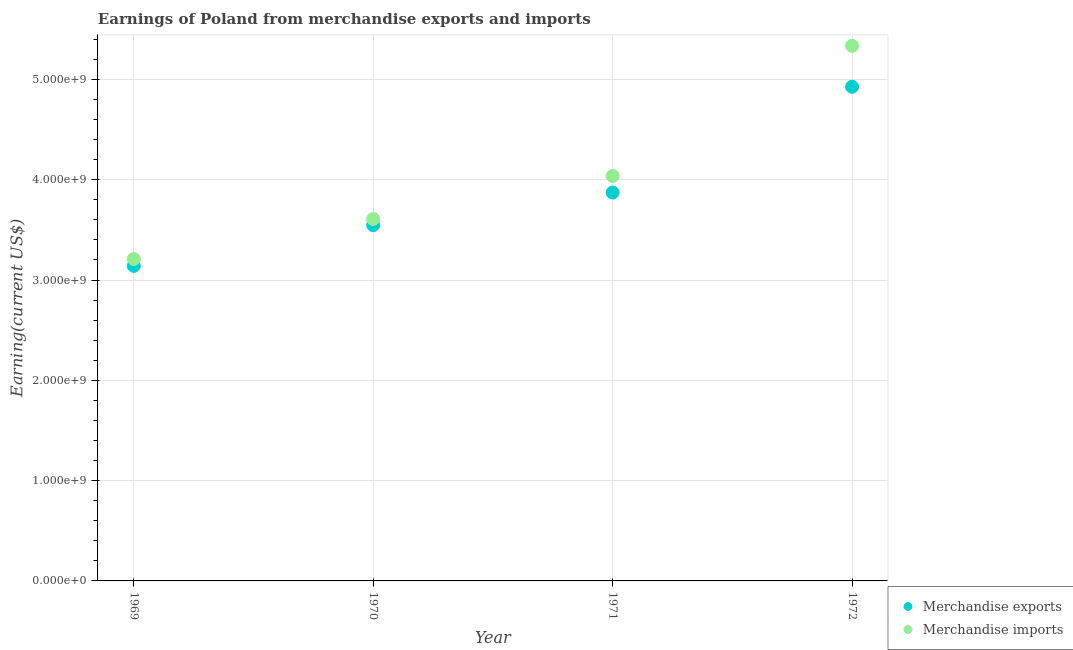What is the earnings from merchandise imports in 1972?
Your answer should be very brief. 5.34e+09. Across all years, what is the maximum earnings from merchandise imports?
Keep it short and to the point. 5.34e+09. Across all years, what is the minimum earnings from merchandise imports?
Offer a terse response. 3.21e+09. In which year was the earnings from merchandise imports minimum?
Provide a short and direct response. 1969. What is the total earnings from merchandise exports in the graph?
Make the answer very short. 1.55e+1. What is the difference between the earnings from merchandise imports in 1970 and that in 1972?
Offer a terse response. -1.73e+09. What is the difference between the earnings from merchandise imports in 1972 and the earnings from merchandise exports in 1971?
Offer a terse response. 1.46e+09. What is the average earnings from merchandise exports per year?
Provide a short and direct response. 3.87e+09. In the year 1972, what is the difference between the earnings from merchandise exports and earnings from merchandise imports?
Ensure brevity in your answer.  -4.08e+08. What is the ratio of the earnings from merchandise imports in 1969 to that in 1972?
Offer a very short reply. 0.6. Is the earnings from merchandise exports in 1970 less than that in 1972?
Provide a short and direct response. Yes. What is the difference between the highest and the second highest earnings from merchandise exports?
Offer a terse response. 1.06e+09. What is the difference between the highest and the lowest earnings from merchandise exports?
Give a very brief answer. 1.79e+09. In how many years, is the earnings from merchandise exports greater than the average earnings from merchandise exports taken over all years?
Ensure brevity in your answer.  2. Is the earnings from merchandise imports strictly greater than the earnings from merchandise exports over the years?
Offer a very short reply. Yes. How many years are there in the graph?
Your answer should be compact. 4. What is the difference between two consecutive major ticks on the Y-axis?
Your answer should be very brief. 1.00e+09. Are the values on the major ticks of Y-axis written in scientific E-notation?
Your answer should be very brief. Yes. Does the graph contain any zero values?
Ensure brevity in your answer.  No. What is the title of the graph?
Your response must be concise. Earnings of Poland from merchandise exports and imports. Does "External balance on goods" appear as one of the legend labels in the graph?
Your answer should be very brief. No. What is the label or title of the X-axis?
Your response must be concise. Year. What is the label or title of the Y-axis?
Offer a very short reply. Earning(current US$). What is the Earning(current US$) of Merchandise exports in 1969?
Make the answer very short. 3.14e+09. What is the Earning(current US$) of Merchandise imports in 1969?
Keep it short and to the point. 3.21e+09. What is the Earning(current US$) of Merchandise exports in 1970?
Ensure brevity in your answer.  3.55e+09. What is the Earning(current US$) of Merchandise imports in 1970?
Offer a terse response. 3.61e+09. What is the Earning(current US$) in Merchandise exports in 1971?
Your response must be concise. 3.87e+09. What is the Earning(current US$) in Merchandise imports in 1971?
Make the answer very short. 4.04e+09. What is the Earning(current US$) of Merchandise exports in 1972?
Give a very brief answer. 4.93e+09. What is the Earning(current US$) of Merchandise imports in 1972?
Offer a terse response. 5.34e+09. Across all years, what is the maximum Earning(current US$) of Merchandise exports?
Provide a short and direct response. 4.93e+09. Across all years, what is the maximum Earning(current US$) of Merchandise imports?
Give a very brief answer. 5.34e+09. Across all years, what is the minimum Earning(current US$) of Merchandise exports?
Offer a terse response. 3.14e+09. Across all years, what is the minimum Earning(current US$) of Merchandise imports?
Ensure brevity in your answer.  3.21e+09. What is the total Earning(current US$) of Merchandise exports in the graph?
Give a very brief answer. 1.55e+1. What is the total Earning(current US$) in Merchandise imports in the graph?
Give a very brief answer. 1.62e+1. What is the difference between the Earning(current US$) of Merchandise exports in 1969 and that in 1970?
Provide a succinct answer. -4.06e+08. What is the difference between the Earning(current US$) of Merchandise imports in 1969 and that in 1970?
Offer a very short reply. -3.98e+08. What is the difference between the Earning(current US$) of Merchandise exports in 1969 and that in 1971?
Your answer should be very brief. -7.31e+08. What is the difference between the Earning(current US$) in Merchandise imports in 1969 and that in 1971?
Ensure brevity in your answer.  -8.28e+08. What is the difference between the Earning(current US$) in Merchandise exports in 1969 and that in 1972?
Provide a succinct answer. -1.79e+09. What is the difference between the Earning(current US$) of Merchandise imports in 1969 and that in 1972?
Provide a succinct answer. -2.12e+09. What is the difference between the Earning(current US$) of Merchandise exports in 1970 and that in 1971?
Provide a short and direct response. -3.25e+08. What is the difference between the Earning(current US$) in Merchandise imports in 1970 and that in 1971?
Offer a terse response. -4.30e+08. What is the difference between the Earning(current US$) of Merchandise exports in 1970 and that in 1972?
Provide a short and direct response. -1.38e+09. What is the difference between the Earning(current US$) of Merchandise imports in 1970 and that in 1972?
Your answer should be compact. -1.73e+09. What is the difference between the Earning(current US$) in Merchandise exports in 1971 and that in 1972?
Your answer should be very brief. -1.06e+09. What is the difference between the Earning(current US$) of Merchandise imports in 1971 and that in 1972?
Make the answer very short. -1.30e+09. What is the difference between the Earning(current US$) of Merchandise exports in 1969 and the Earning(current US$) of Merchandise imports in 1970?
Your answer should be very brief. -4.66e+08. What is the difference between the Earning(current US$) of Merchandise exports in 1969 and the Earning(current US$) of Merchandise imports in 1971?
Keep it short and to the point. -8.96e+08. What is the difference between the Earning(current US$) of Merchandise exports in 1969 and the Earning(current US$) of Merchandise imports in 1972?
Offer a terse response. -2.19e+09. What is the difference between the Earning(current US$) in Merchandise exports in 1970 and the Earning(current US$) in Merchandise imports in 1971?
Your response must be concise. -4.90e+08. What is the difference between the Earning(current US$) in Merchandise exports in 1970 and the Earning(current US$) in Merchandise imports in 1972?
Give a very brief answer. -1.79e+09. What is the difference between the Earning(current US$) of Merchandise exports in 1971 and the Earning(current US$) of Merchandise imports in 1972?
Your answer should be compact. -1.46e+09. What is the average Earning(current US$) in Merchandise exports per year?
Make the answer very short. 3.87e+09. What is the average Earning(current US$) of Merchandise imports per year?
Provide a short and direct response. 4.05e+09. In the year 1969, what is the difference between the Earning(current US$) in Merchandise exports and Earning(current US$) in Merchandise imports?
Offer a very short reply. -6.85e+07. In the year 1970, what is the difference between the Earning(current US$) of Merchandise exports and Earning(current US$) of Merchandise imports?
Ensure brevity in your answer.  -6.04e+07. In the year 1971, what is the difference between the Earning(current US$) of Merchandise exports and Earning(current US$) of Merchandise imports?
Your response must be concise. -1.66e+08. In the year 1972, what is the difference between the Earning(current US$) in Merchandise exports and Earning(current US$) in Merchandise imports?
Offer a terse response. -4.08e+08. What is the ratio of the Earning(current US$) of Merchandise exports in 1969 to that in 1970?
Offer a terse response. 0.89. What is the ratio of the Earning(current US$) of Merchandise imports in 1969 to that in 1970?
Make the answer very short. 0.89. What is the ratio of the Earning(current US$) of Merchandise exports in 1969 to that in 1971?
Your answer should be very brief. 0.81. What is the ratio of the Earning(current US$) of Merchandise imports in 1969 to that in 1971?
Your response must be concise. 0.79. What is the ratio of the Earning(current US$) of Merchandise exports in 1969 to that in 1972?
Keep it short and to the point. 0.64. What is the ratio of the Earning(current US$) of Merchandise imports in 1969 to that in 1972?
Give a very brief answer. 0.6. What is the ratio of the Earning(current US$) of Merchandise exports in 1970 to that in 1971?
Ensure brevity in your answer.  0.92. What is the ratio of the Earning(current US$) in Merchandise imports in 1970 to that in 1971?
Your response must be concise. 0.89. What is the ratio of the Earning(current US$) in Merchandise exports in 1970 to that in 1972?
Ensure brevity in your answer.  0.72. What is the ratio of the Earning(current US$) in Merchandise imports in 1970 to that in 1972?
Offer a very short reply. 0.68. What is the ratio of the Earning(current US$) of Merchandise exports in 1971 to that in 1972?
Keep it short and to the point. 0.79. What is the ratio of the Earning(current US$) of Merchandise imports in 1971 to that in 1972?
Your answer should be very brief. 0.76. What is the difference between the highest and the second highest Earning(current US$) of Merchandise exports?
Your answer should be compact. 1.06e+09. What is the difference between the highest and the second highest Earning(current US$) of Merchandise imports?
Offer a terse response. 1.30e+09. What is the difference between the highest and the lowest Earning(current US$) in Merchandise exports?
Keep it short and to the point. 1.79e+09. What is the difference between the highest and the lowest Earning(current US$) in Merchandise imports?
Provide a succinct answer. 2.12e+09. 